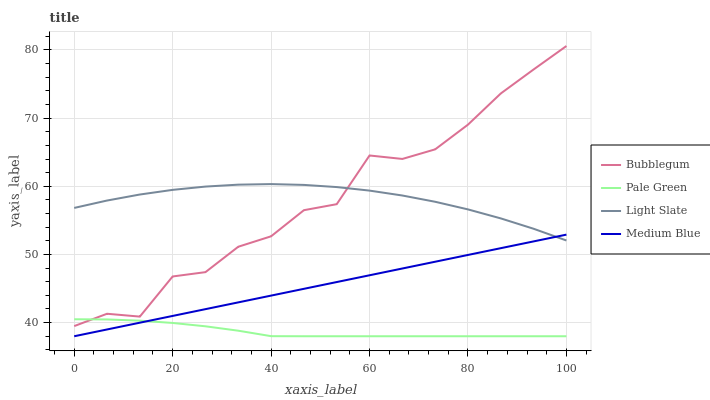Does Pale Green have the minimum area under the curve?
Answer yes or no. Yes. Does Light Slate have the maximum area under the curve?
Answer yes or no. Yes. Does Medium Blue have the minimum area under the curve?
Answer yes or no. No. Does Medium Blue have the maximum area under the curve?
Answer yes or no. No. Is Medium Blue the smoothest?
Answer yes or no. Yes. Is Bubblegum the roughest?
Answer yes or no. Yes. Is Pale Green the smoothest?
Answer yes or no. No. Is Pale Green the roughest?
Answer yes or no. No. Does Pale Green have the lowest value?
Answer yes or no. Yes. Does Bubblegum have the lowest value?
Answer yes or no. No. Does Bubblegum have the highest value?
Answer yes or no. Yes. Does Medium Blue have the highest value?
Answer yes or no. No. Is Medium Blue less than Bubblegum?
Answer yes or no. Yes. Is Light Slate greater than Pale Green?
Answer yes or no. Yes. Does Pale Green intersect Medium Blue?
Answer yes or no. Yes. Is Pale Green less than Medium Blue?
Answer yes or no. No. Is Pale Green greater than Medium Blue?
Answer yes or no. No. Does Medium Blue intersect Bubblegum?
Answer yes or no. No. 